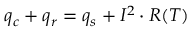Convert formula to latex. <formula><loc_0><loc_0><loc_500><loc_500>\begin{array} { r } { q _ { c } + q _ { r } = q _ { s } + I ^ { 2 } \cdot R ( T ) } \end{array}</formula> 